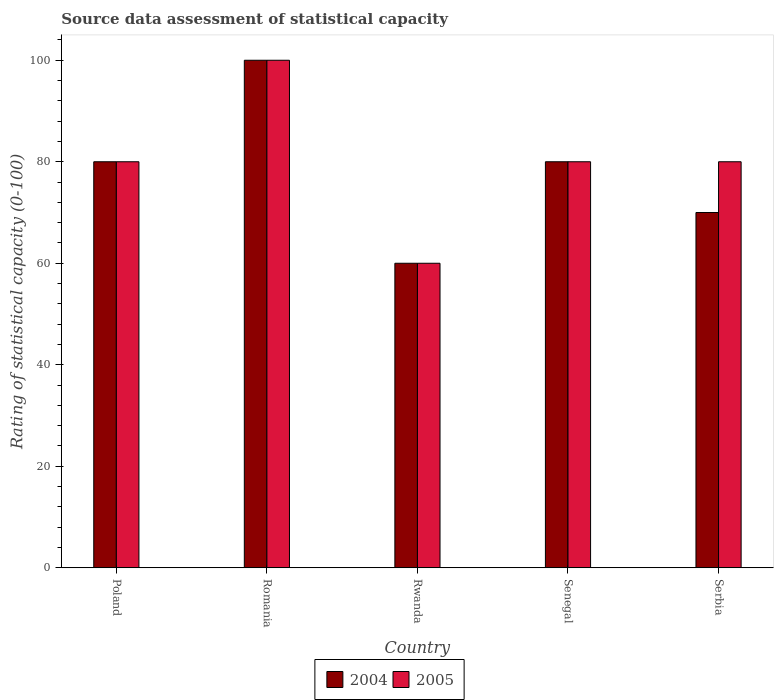How many groups of bars are there?
Provide a succinct answer. 5. Are the number of bars per tick equal to the number of legend labels?
Make the answer very short. Yes. Are the number of bars on each tick of the X-axis equal?
Your response must be concise. Yes. How many bars are there on the 5th tick from the right?
Your answer should be very brief. 2. What is the label of the 4th group of bars from the left?
Ensure brevity in your answer.  Senegal. In how many cases, is the number of bars for a given country not equal to the number of legend labels?
Give a very brief answer. 0. What is the rating of statistical capacity in 2004 in Poland?
Provide a succinct answer. 80. Across all countries, what is the maximum rating of statistical capacity in 2004?
Your answer should be compact. 100. In which country was the rating of statistical capacity in 2004 maximum?
Offer a very short reply. Romania. In which country was the rating of statistical capacity in 2004 minimum?
Make the answer very short. Rwanda. What is the difference between the rating of statistical capacity in 2004 in Senegal and the rating of statistical capacity in 2005 in Rwanda?
Give a very brief answer. 20. What is the difference between the rating of statistical capacity of/in 2005 and rating of statistical capacity of/in 2004 in Serbia?
Your answer should be very brief. 10. In how many countries, is the rating of statistical capacity in 2005 greater than 16?
Offer a very short reply. 5. Is the rating of statistical capacity in 2005 in Poland less than that in Senegal?
Your answer should be very brief. No. Is the difference between the rating of statistical capacity in 2005 in Romania and Senegal greater than the difference between the rating of statistical capacity in 2004 in Romania and Senegal?
Make the answer very short. No. What is the difference between the highest and the second highest rating of statistical capacity in 2004?
Your answer should be compact. -20. What is the difference between the highest and the lowest rating of statistical capacity in 2005?
Keep it short and to the point. 40. Is the sum of the rating of statistical capacity in 2004 in Poland and Serbia greater than the maximum rating of statistical capacity in 2005 across all countries?
Give a very brief answer. Yes. What does the 1st bar from the left in Senegal represents?
Provide a succinct answer. 2004. What does the 2nd bar from the right in Romania represents?
Your answer should be compact. 2004. How many countries are there in the graph?
Your answer should be very brief. 5. Are the values on the major ticks of Y-axis written in scientific E-notation?
Give a very brief answer. No. Does the graph contain any zero values?
Your response must be concise. No. Where does the legend appear in the graph?
Offer a terse response. Bottom center. What is the title of the graph?
Give a very brief answer. Source data assessment of statistical capacity. What is the label or title of the Y-axis?
Provide a short and direct response. Rating of statistical capacity (0-100). What is the Rating of statistical capacity (0-100) in 2005 in Poland?
Ensure brevity in your answer.  80. What is the Rating of statistical capacity (0-100) of 2004 in Romania?
Your response must be concise. 100. What is the Rating of statistical capacity (0-100) of 2005 in Romania?
Keep it short and to the point. 100. What is the Rating of statistical capacity (0-100) in 2005 in Rwanda?
Your answer should be compact. 60. Across all countries, what is the minimum Rating of statistical capacity (0-100) in 2005?
Give a very brief answer. 60. What is the total Rating of statistical capacity (0-100) in 2004 in the graph?
Provide a short and direct response. 390. What is the total Rating of statistical capacity (0-100) of 2005 in the graph?
Offer a terse response. 400. What is the difference between the Rating of statistical capacity (0-100) of 2005 in Poland and that in Romania?
Offer a terse response. -20. What is the difference between the Rating of statistical capacity (0-100) in 2004 in Poland and that in Rwanda?
Offer a very short reply. 20. What is the difference between the Rating of statistical capacity (0-100) of 2004 in Poland and that in Senegal?
Keep it short and to the point. 0. What is the difference between the Rating of statistical capacity (0-100) of 2005 in Poland and that in Senegal?
Your answer should be compact. 0. What is the difference between the Rating of statistical capacity (0-100) of 2004 in Poland and that in Serbia?
Make the answer very short. 10. What is the difference between the Rating of statistical capacity (0-100) in 2005 in Poland and that in Serbia?
Offer a terse response. 0. What is the difference between the Rating of statistical capacity (0-100) in 2005 in Romania and that in Rwanda?
Offer a terse response. 40. What is the difference between the Rating of statistical capacity (0-100) of 2005 in Romania and that in Serbia?
Keep it short and to the point. 20. What is the difference between the Rating of statistical capacity (0-100) in 2004 in Rwanda and that in Senegal?
Provide a succinct answer. -20. What is the difference between the Rating of statistical capacity (0-100) of 2004 in Rwanda and that in Serbia?
Keep it short and to the point. -10. What is the difference between the Rating of statistical capacity (0-100) of 2004 in Poland and the Rating of statistical capacity (0-100) of 2005 in Romania?
Provide a short and direct response. -20. What is the difference between the Rating of statistical capacity (0-100) of 2004 in Poland and the Rating of statistical capacity (0-100) of 2005 in Senegal?
Make the answer very short. 0. What is the difference between the Rating of statistical capacity (0-100) of 2004 in Romania and the Rating of statistical capacity (0-100) of 2005 in Rwanda?
Your answer should be very brief. 40. What is the difference between the Rating of statistical capacity (0-100) of 2004 in Romania and the Rating of statistical capacity (0-100) of 2005 in Serbia?
Provide a short and direct response. 20. What is the average Rating of statistical capacity (0-100) of 2004 per country?
Offer a terse response. 78. What is the average Rating of statistical capacity (0-100) in 2005 per country?
Your answer should be very brief. 80. What is the difference between the Rating of statistical capacity (0-100) of 2004 and Rating of statistical capacity (0-100) of 2005 in Poland?
Give a very brief answer. 0. What is the difference between the Rating of statistical capacity (0-100) in 2004 and Rating of statistical capacity (0-100) in 2005 in Senegal?
Give a very brief answer. 0. What is the difference between the Rating of statistical capacity (0-100) in 2004 and Rating of statistical capacity (0-100) in 2005 in Serbia?
Provide a succinct answer. -10. What is the ratio of the Rating of statistical capacity (0-100) in 2004 in Poland to that in Romania?
Provide a short and direct response. 0.8. What is the ratio of the Rating of statistical capacity (0-100) of 2005 in Poland to that in Romania?
Provide a succinct answer. 0.8. What is the ratio of the Rating of statistical capacity (0-100) of 2004 in Poland to that in Senegal?
Provide a succinct answer. 1. What is the ratio of the Rating of statistical capacity (0-100) of 2004 in Poland to that in Serbia?
Make the answer very short. 1.14. What is the ratio of the Rating of statistical capacity (0-100) of 2005 in Poland to that in Serbia?
Offer a terse response. 1. What is the ratio of the Rating of statistical capacity (0-100) of 2005 in Romania to that in Rwanda?
Offer a terse response. 1.67. What is the ratio of the Rating of statistical capacity (0-100) in 2004 in Romania to that in Senegal?
Your response must be concise. 1.25. What is the ratio of the Rating of statistical capacity (0-100) of 2004 in Romania to that in Serbia?
Your response must be concise. 1.43. What is the ratio of the Rating of statistical capacity (0-100) in 2005 in Rwanda to that in Senegal?
Ensure brevity in your answer.  0.75. What is the ratio of the Rating of statistical capacity (0-100) of 2004 in Rwanda to that in Serbia?
Your answer should be compact. 0.86. What is the ratio of the Rating of statistical capacity (0-100) in 2004 in Senegal to that in Serbia?
Offer a terse response. 1.14. What is the difference between the highest and the second highest Rating of statistical capacity (0-100) of 2005?
Keep it short and to the point. 20. 